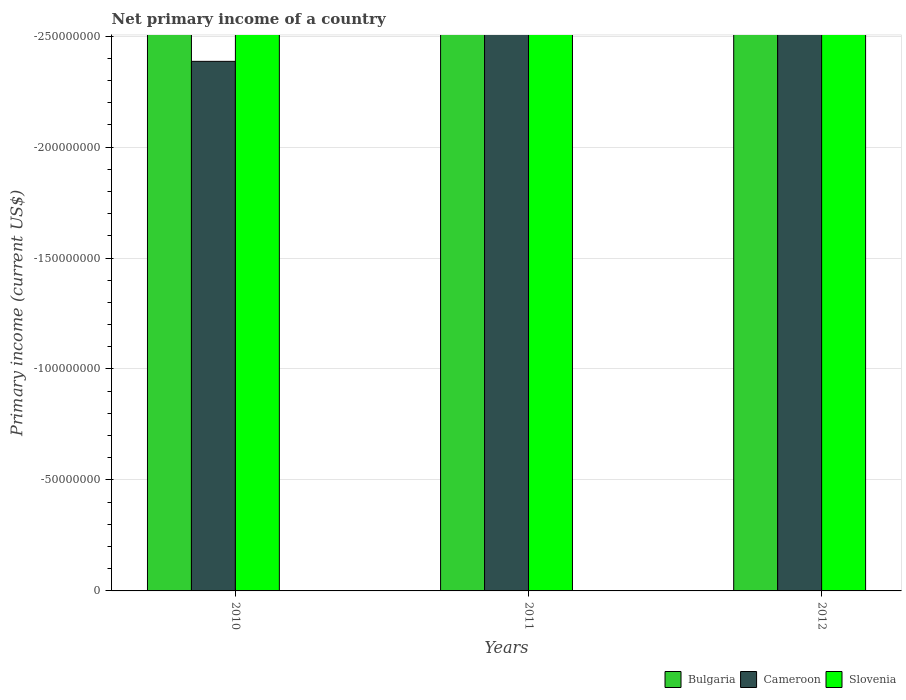How many different coloured bars are there?
Offer a terse response. 0. Are the number of bars per tick equal to the number of legend labels?
Provide a short and direct response. No. Are the number of bars on each tick of the X-axis equal?
Make the answer very short. Yes. What is the primary income in Cameroon in 2012?
Make the answer very short. 0. In how many years, is the primary income in Cameroon greater than -190000000 US$?
Your answer should be compact. 0. In how many years, is the primary income in Cameroon greater than the average primary income in Cameroon taken over all years?
Your answer should be compact. 0. Is it the case that in every year, the sum of the primary income in Cameroon and primary income in Slovenia is greater than the primary income in Bulgaria?
Your answer should be compact. No. How many years are there in the graph?
Provide a short and direct response. 3. Are the values on the major ticks of Y-axis written in scientific E-notation?
Your answer should be very brief. No. Does the graph contain any zero values?
Make the answer very short. Yes. Where does the legend appear in the graph?
Provide a succinct answer. Bottom right. How are the legend labels stacked?
Provide a short and direct response. Horizontal. What is the title of the graph?
Make the answer very short. Net primary income of a country. What is the label or title of the X-axis?
Make the answer very short. Years. What is the label or title of the Y-axis?
Keep it short and to the point. Primary income (current US$). What is the Primary income (current US$) of Bulgaria in 2011?
Offer a very short reply. 0. What is the Primary income (current US$) of Cameroon in 2011?
Your response must be concise. 0. What is the average Primary income (current US$) in Slovenia per year?
Offer a very short reply. 0. 